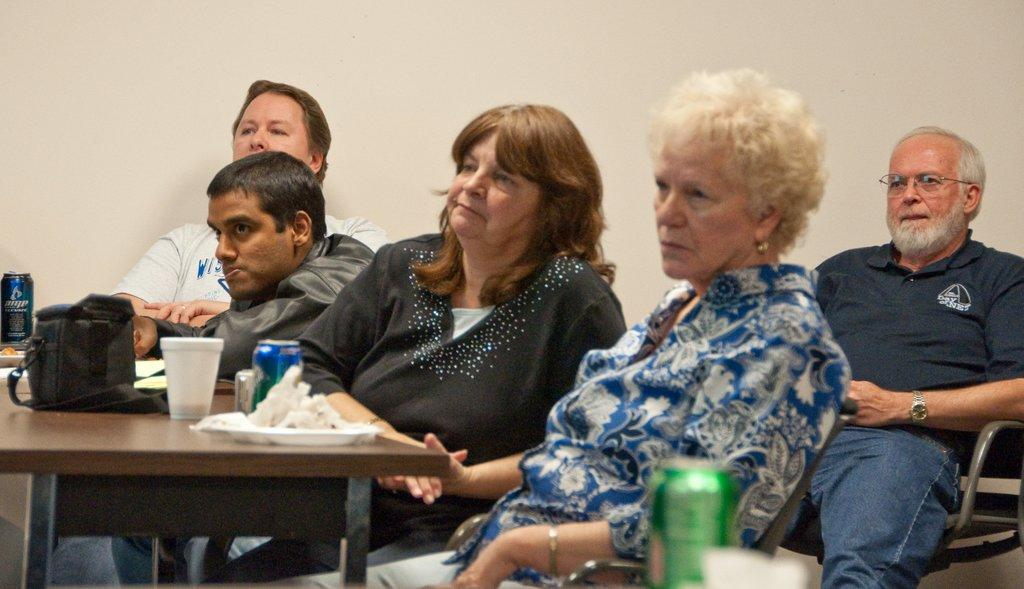What are the people in the image doing? The people in the image are sitting in chairs. Where are the chairs located in relation to the table? The chairs are in front of the table. What items can be seen on the table? Plates, cups, tins, and bags are placed on the table. What is visible in the background of the image? There is a wall in the background. What direction is the crate facing in the image? There is no crate present in the image. Can you tell me how many receipts are on the table? There is no mention of receipts in the image; only plates, cups, tins, and bags are present on the table. 